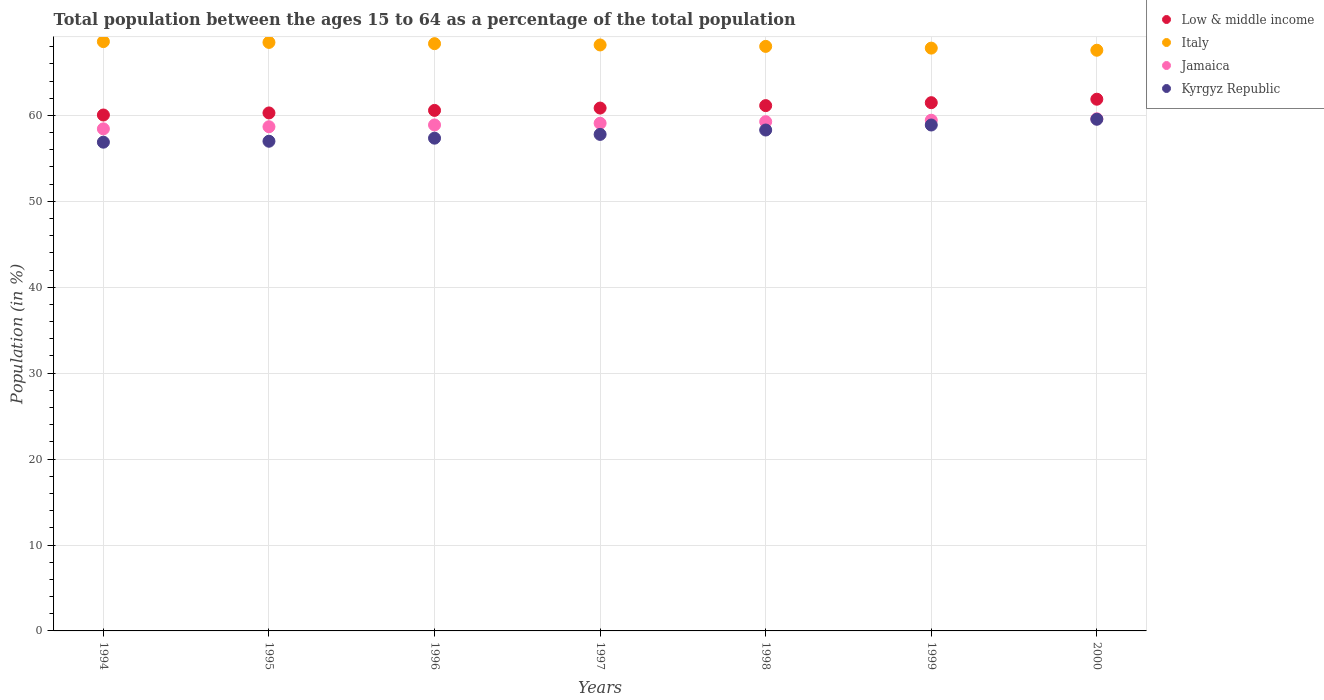How many different coloured dotlines are there?
Your answer should be very brief. 4. What is the percentage of the population ages 15 to 64 in Jamaica in 1996?
Offer a very short reply. 58.89. Across all years, what is the maximum percentage of the population ages 15 to 64 in Jamaica?
Your answer should be very brief. 59.61. Across all years, what is the minimum percentage of the population ages 15 to 64 in Jamaica?
Offer a very short reply. 58.43. In which year was the percentage of the population ages 15 to 64 in Low & middle income maximum?
Keep it short and to the point. 2000. In which year was the percentage of the population ages 15 to 64 in Jamaica minimum?
Make the answer very short. 1994. What is the total percentage of the population ages 15 to 64 in Low & middle income in the graph?
Provide a short and direct response. 426.27. What is the difference between the percentage of the population ages 15 to 64 in Low & middle income in 1996 and that in 1998?
Your answer should be compact. -0.56. What is the difference between the percentage of the population ages 15 to 64 in Low & middle income in 1998 and the percentage of the population ages 15 to 64 in Kyrgyz Republic in 1994?
Provide a succinct answer. 4.26. What is the average percentage of the population ages 15 to 64 in Kyrgyz Republic per year?
Provide a succinct answer. 57.96. In the year 1994, what is the difference between the percentage of the population ages 15 to 64 in Jamaica and percentage of the population ages 15 to 64 in Low & middle income?
Your answer should be very brief. -1.61. What is the ratio of the percentage of the population ages 15 to 64 in Kyrgyz Republic in 1994 to that in 1998?
Offer a terse response. 0.98. What is the difference between the highest and the second highest percentage of the population ages 15 to 64 in Jamaica?
Your answer should be very brief. 0.17. What is the difference between the highest and the lowest percentage of the population ages 15 to 64 in Italy?
Your answer should be very brief. 1.01. Is the sum of the percentage of the population ages 15 to 64 in Low & middle income in 1999 and 2000 greater than the maximum percentage of the population ages 15 to 64 in Kyrgyz Republic across all years?
Ensure brevity in your answer.  Yes. Is it the case that in every year, the sum of the percentage of the population ages 15 to 64 in Kyrgyz Republic and percentage of the population ages 15 to 64 in Jamaica  is greater than the sum of percentage of the population ages 15 to 64 in Low & middle income and percentage of the population ages 15 to 64 in Italy?
Provide a succinct answer. No. Does the percentage of the population ages 15 to 64 in Kyrgyz Republic monotonically increase over the years?
Offer a very short reply. Yes. How many years are there in the graph?
Ensure brevity in your answer.  7. What is the difference between two consecutive major ticks on the Y-axis?
Provide a succinct answer. 10. Are the values on the major ticks of Y-axis written in scientific E-notation?
Your answer should be very brief. No. What is the title of the graph?
Make the answer very short. Total population between the ages 15 to 64 as a percentage of the total population. What is the label or title of the X-axis?
Your answer should be very brief. Years. What is the label or title of the Y-axis?
Give a very brief answer. Population (in %). What is the Population (in %) in Low & middle income in 1994?
Provide a short and direct response. 60.05. What is the Population (in %) in Italy in 1994?
Provide a short and direct response. 68.59. What is the Population (in %) in Jamaica in 1994?
Ensure brevity in your answer.  58.43. What is the Population (in %) of Kyrgyz Republic in 1994?
Provide a short and direct response. 56.88. What is the Population (in %) in Low & middle income in 1995?
Make the answer very short. 60.29. What is the Population (in %) in Italy in 1995?
Your answer should be very brief. 68.5. What is the Population (in %) of Jamaica in 1995?
Offer a terse response. 58.68. What is the Population (in %) in Kyrgyz Republic in 1995?
Your answer should be compact. 56.99. What is the Population (in %) in Low & middle income in 1996?
Provide a succinct answer. 60.58. What is the Population (in %) in Italy in 1996?
Your response must be concise. 68.35. What is the Population (in %) in Jamaica in 1996?
Make the answer very short. 58.89. What is the Population (in %) in Kyrgyz Republic in 1996?
Your answer should be compact. 57.35. What is the Population (in %) of Low & middle income in 1997?
Your answer should be compact. 60.85. What is the Population (in %) in Italy in 1997?
Provide a succinct answer. 68.2. What is the Population (in %) in Jamaica in 1997?
Keep it short and to the point. 59.09. What is the Population (in %) in Kyrgyz Republic in 1997?
Provide a short and direct response. 57.79. What is the Population (in %) in Low & middle income in 1998?
Your response must be concise. 61.14. What is the Population (in %) of Italy in 1998?
Keep it short and to the point. 68.03. What is the Population (in %) of Jamaica in 1998?
Make the answer very short. 59.27. What is the Population (in %) of Kyrgyz Republic in 1998?
Make the answer very short. 58.3. What is the Population (in %) of Low & middle income in 1999?
Offer a terse response. 61.48. What is the Population (in %) of Italy in 1999?
Give a very brief answer. 67.83. What is the Population (in %) of Jamaica in 1999?
Provide a succinct answer. 59.44. What is the Population (in %) of Kyrgyz Republic in 1999?
Give a very brief answer. 58.88. What is the Population (in %) in Low & middle income in 2000?
Give a very brief answer. 61.88. What is the Population (in %) in Italy in 2000?
Your answer should be very brief. 67.58. What is the Population (in %) of Jamaica in 2000?
Ensure brevity in your answer.  59.61. What is the Population (in %) of Kyrgyz Republic in 2000?
Your answer should be very brief. 59.55. Across all years, what is the maximum Population (in %) of Low & middle income?
Ensure brevity in your answer.  61.88. Across all years, what is the maximum Population (in %) of Italy?
Keep it short and to the point. 68.59. Across all years, what is the maximum Population (in %) of Jamaica?
Your answer should be very brief. 59.61. Across all years, what is the maximum Population (in %) of Kyrgyz Republic?
Provide a succinct answer. 59.55. Across all years, what is the minimum Population (in %) in Low & middle income?
Keep it short and to the point. 60.05. Across all years, what is the minimum Population (in %) in Italy?
Offer a terse response. 67.58. Across all years, what is the minimum Population (in %) of Jamaica?
Make the answer very short. 58.43. Across all years, what is the minimum Population (in %) of Kyrgyz Republic?
Ensure brevity in your answer.  56.88. What is the total Population (in %) in Low & middle income in the graph?
Ensure brevity in your answer.  426.27. What is the total Population (in %) in Italy in the graph?
Provide a short and direct response. 477.08. What is the total Population (in %) of Jamaica in the graph?
Your answer should be very brief. 413.41. What is the total Population (in %) in Kyrgyz Republic in the graph?
Your answer should be compact. 405.75. What is the difference between the Population (in %) of Low & middle income in 1994 and that in 1995?
Offer a very short reply. -0.24. What is the difference between the Population (in %) of Italy in 1994 and that in 1995?
Provide a succinct answer. 0.09. What is the difference between the Population (in %) in Jamaica in 1994 and that in 1995?
Your answer should be compact. -0.25. What is the difference between the Population (in %) in Kyrgyz Republic in 1994 and that in 1995?
Keep it short and to the point. -0.11. What is the difference between the Population (in %) in Low & middle income in 1994 and that in 1996?
Your answer should be compact. -0.54. What is the difference between the Population (in %) in Italy in 1994 and that in 1996?
Provide a succinct answer. 0.24. What is the difference between the Population (in %) in Jamaica in 1994 and that in 1996?
Your answer should be very brief. -0.45. What is the difference between the Population (in %) of Kyrgyz Republic in 1994 and that in 1996?
Offer a very short reply. -0.47. What is the difference between the Population (in %) of Low & middle income in 1994 and that in 1997?
Provide a succinct answer. -0.81. What is the difference between the Population (in %) of Italy in 1994 and that in 1997?
Keep it short and to the point. 0.39. What is the difference between the Population (in %) in Jamaica in 1994 and that in 1997?
Provide a short and direct response. -0.65. What is the difference between the Population (in %) of Kyrgyz Republic in 1994 and that in 1997?
Provide a short and direct response. -0.91. What is the difference between the Population (in %) in Low & middle income in 1994 and that in 1998?
Your response must be concise. -1.09. What is the difference between the Population (in %) in Italy in 1994 and that in 1998?
Provide a succinct answer. 0.56. What is the difference between the Population (in %) in Jamaica in 1994 and that in 1998?
Provide a short and direct response. -0.84. What is the difference between the Population (in %) of Kyrgyz Republic in 1994 and that in 1998?
Your answer should be compact. -1.41. What is the difference between the Population (in %) of Low & middle income in 1994 and that in 1999?
Ensure brevity in your answer.  -1.43. What is the difference between the Population (in %) of Italy in 1994 and that in 1999?
Make the answer very short. 0.76. What is the difference between the Population (in %) of Jamaica in 1994 and that in 1999?
Your answer should be very brief. -1.01. What is the difference between the Population (in %) in Kyrgyz Republic in 1994 and that in 1999?
Your response must be concise. -2. What is the difference between the Population (in %) in Low & middle income in 1994 and that in 2000?
Offer a very short reply. -1.84. What is the difference between the Population (in %) of Italy in 1994 and that in 2000?
Offer a very short reply. 1. What is the difference between the Population (in %) of Jamaica in 1994 and that in 2000?
Provide a short and direct response. -1.17. What is the difference between the Population (in %) of Kyrgyz Republic in 1994 and that in 2000?
Keep it short and to the point. -2.67. What is the difference between the Population (in %) of Low & middle income in 1995 and that in 1996?
Keep it short and to the point. -0.3. What is the difference between the Population (in %) in Italy in 1995 and that in 1996?
Offer a very short reply. 0.14. What is the difference between the Population (in %) in Jamaica in 1995 and that in 1996?
Provide a succinct answer. -0.21. What is the difference between the Population (in %) in Kyrgyz Republic in 1995 and that in 1996?
Your response must be concise. -0.36. What is the difference between the Population (in %) in Low & middle income in 1995 and that in 1997?
Your answer should be compact. -0.57. What is the difference between the Population (in %) of Italy in 1995 and that in 1997?
Give a very brief answer. 0.3. What is the difference between the Population (in %) of Jamaica in 1995 and that in 1997?
Offer a terse response. -0.4. What is the difference between the Population (in %) in Kyrgyz Republic in 1995 and that in 1997?
Offer a terse response. -0.8. What is the difference between the Population (in %) in Low & middle income in 1995 and that in 1998?
Offer a very short reply. -0.85. What is the difference between the Population (in %) of Italy in 1995 and that in 1998?
Make the answer very short. 0.46. What is the difference between the Population (in %) of Jamaica in 1995 and that in 1998?
Provide a succinct answer. -0.59. What is the difference between the Population (in %) of Kyrgyz Republic in 1995 and that in 1998?
Provide a succinct answer. -1.31. What is the difference between the Population (in %) of Low & middle income in 1995 and that in 1999?
Make the answer very short. -1.19. What is the difference between the Population (in %) of Italy in 1995 and that in 1999?
Your answer should be compact. 0.66. What is the difference between the Population (in %) of Jamaica in 1995 and that in 1999?
Keep it short and to the point. -0.76. What is the difference between the Population (in %) of Kyrgyz Republic in 1995 and that in 1999?
Offer a terse response. -1.89. What is the difference between the Population (in %) in Low & middle income in 1995 and that in 2000?
Keep it short and to the point. -1.6. What is the difference between the Population (in %) of Italy in 1995 and that in 2000?
Provide a short and direct response. 0.91. What is the difference between the Population (in %) in Jamaica in 1995 and that in 2000?
Offer a very short reply. -0.93. What is the difference between the Population (in %) in Kyrgyz Republic in 1995 and that in 2000?
Your answer should be compact. -2.56. What is the difference between the Population (in %) of Low & middle income in 1996 and that in 1997?
Your response must be concise. -0.27. What is the difference between the Population (in %) in Italy in 1996 and that in 1997?
Make the answer very short. 0.15. What is the difference between the Population (in %) of Jamaica in 1996 and that in 1997?
Provide a succinct answer. -0.2. What is the difference between the Population (in %) in Kyrgyz Republic in 1996 and that in 1997?
Ensure brevity in your answer.  -0.44. What is the difference between the Population (in %) of Low & middle income in 1996 and that in 1998?
Give a very brief answer. -0.56. What is the difference between the Population (in %) in Italy in 1996 and that in 1998?
Offer a very short reply. 0.32. What is the difference between the Population (in %) of Jamaica in 1996 and that in 1998?
Provide a succinct answer. -0.38. What is the difference between the Population (in %) of Kyrgyz Republic in 1996 and that in 1998?
Your answer should be compact. -0.95. What is the difference between the Population (in %) in Low & middle income in 1996 and that in 1999?
Your answer should be very brief. -0.9. What is the difference between the Population (in %) of Italy in 1996 and that in 1999?
Make the answer very short. 0.52. What is the difference between the Population (in %) of Jamaica in 1996 and that in 1999?
Your answer should be very brief. -0.55. What is the difference between the Population (in %) of Kyrgyz Republic in 1996 and that in 1999?
Provide a succinct answer. -1.53. What is the difference between the Population (in %) of Low & middle income in 1996 and that in 2000?
Make the answer very short. -1.3. What is the difference between the Population (in %) of Italy in 1996 and that in 2000?
Your response must be concise. 0.77. What is the difference between the Population (in %) in Jamaica in 1996 and that in 2000?
Your response must be concise. -0.72. What is the difference between the Population (in %) in Kyrgyz Republic in 1996 and that in 2000?
Your answer should be compact. -2.2. What is the difference between the Population (in %) of Low & middle income in 1997 and that in 1998?
Provide a short and direct response. -0.28. What is the difference between the Population (in %) of Italy in 1997 and that in 1998?
Your answer should be compact. 0.17. What is the difference between the Population (in %) in Jamaica in 1997 and that in 1998?
Ensure brevity in your answer.  -0.19. What is the difference between the Population (in %) in Kyrgyz Republic in 1997 and that in 1998?
Keep it short and to the point. -0.51. What is the difference between the Population (in %) in Low & middle income in 1997 and that in 1999?
Ensure brevity in your answer.  -0.63. What is the difference between the Population (in %) in Italy in 1997 and that in 1999?
Ensure brevity in your answer.  0.37. What is the difference between the Population (in %) of Jamaica in 1997 and that in 1999?
Your answer should be compact. -0.35. What is the difference between the Population (in %) in Kyrgyz Republic in 1997 and that in 1999?
Your response must be concise. -1.09. What is the difference between the Population (in %) in Low & middle income in 1997 and that in 2000?
Your answer should be compact. -1.03. What is the difference between the Population (in %) in Italy in 1997 and that in 2000?
Your answer should be very brief. 0.62. What is the difference between the Population (in %) in Jamaica in 1997 and that in 2000?
Make the answer very short. -0.52. What is the difference between the Population (in %) of Kyrgyz Republic in 1997 and that in 2000?
Offer a terse response. -1.76. What is the difference between the Population (in %) in Low & middle income in 1998 and that in 1999?
Provide a succinct answer. -0.34. What is the difference between the Population (in %) of Italy in 1998 and that in 1999?
Ensure brevity in your answer.  0.2. What is the difference between the Population (in %) in Jamaica in 1998 and that in 1999?
Your answer should be very brief. -0.17. What is the difference between the Population (in %) in Kyrgyz Republic in 1998 and that in 1999?
Give a very brief answer. -0.58. What is the difference between the Population (in %) of Low & middle income in 1998 and that in 2000?
Your answer should be compact. -0.75. What is the difference between the Population (in %) of Italy in 1998 and that in 2000?
Provide a short and direct response. 0.45. What is the difference between the Population (in %) of Jamaica in 1998 and that in 2000?
Offer a very short reply. -0.34. What is the difference between the Population (in %) of Kyrgyz Republic in 1998 and that in 2000?
Give a very brief answer. -1.25. What is the difference between the Population (in %) in Low & middle income in 1999 and that in 2000?
Give a very brief answer. -0.4. What is the difference between the Population (in %) in Italy in 1999 and that in 2000?
Your answer should be compact. 0.25. What is the difference between the Population (in %) of Jamaica in 1999 and that in 2000?
Make the answer very short. -0.17. What is the difference between the Population (in %) of Kyrgyz Republic in 1999 and that in 2000?
Provide a succinct answer. -0.67. What is the difference between the Population (in %) in Low & middle income in 1994 and the Population (in %) in Italy in 1995?
Keep it short and to the point. -8.45. What is the difference between the Population (in %) of Low & middle income in 1994 and the Population (in %) of Jamaica in 1995?
Offer a very short reply. 1.37. What is the difference between the Population (in %) of Low & middle income in 1994 and the Population (in %) of Kyrgyz Republic in 1995?
Your answer should be very brief. 3.05. What is the difference between the Population (in %) in Italy in 1994 and the Population (in %) in Jamaica in 1995?
Offer a terse response. 9.91. What is the difference between the Population (in %) in Italy in 1994 and the Population (in %) in Kyrgyz Republic in 1995?
Keep it short and to the point. 11.6. What is the difference between the Population (in %) of Jamaica in 1994 and the Population (in %) of Kyrgyz Republic in 1995?
Make the answer very short. 1.44. What is the difference between the Population (in %) of Low & middle income in 1994 and the Population (in %) of Italy in 1996?
Provide a succinct answer. -8.3. What is the difference between the Population (in %) of Low & middle income in 1994 and the Population (in %) of Jamaica in 1996?
Provide a short and direct response. 1.16. What is the difference between the Population (in %) of Low & middle income in 1994 and the Population (in %) of Kyrgyz Republic in 1996?
Your response must be concise. 2.7. What is the difference between the Population (in %) of Italy in 1994 and the Population (in %) of Jamaica in 1996?
Your answer should be compact. 9.7. What is the difference between the Population (in %) in Italy in 1994 and the Population (in %) in Kyrgyz Republic in 1996?
Your response must be concise. 11.24. What is the difference between the Population (in %) in Jamaica in 1994 and the Population (in %) in Kyrgyz Republic in 1996?
Keep it short and to the point. 1.08. What is the difference between the Population (in %) of Low & middle income in 1994 and the Population (in %) of Italy in 1997?
Your response must be concise. -8.15. What is the difference between the Population (in %) in Low & middle income in 1994 and the Population (in %) in Jamaica in 1997?
Make the answer very short. 0.96. What is the difference between the Population (in %) in Low & middle income in 1994 and the Population (in %) in Kyrgyz Republic in 1997?
Provide a succinct answer. 2.26. What is the difference between the Population (in %) in Italy in 1994 and the Population (in %) in Jamaica in 1997?
Provide a short and direct response. 9.5. What is the difference between the Population (in %) in Italy in 1994 and the Population (in %) in Kyrgyz Republic in 1997?
Offer a very short reply. 10.8. What is the difference between the Population (in %) in Jamaica in 1994 and the Population (in %) in Kyrgyz Republic in 1997?
Offer a very short reply. 0.64. What is the difference between the Population (in %) in Low & middle income in 1994 and the Population (in %) in Italy in 1998?
Make the answer very short. -7.99. What is the difference between the Population (in %) of Low & middle income in 1994 and the Population (in %) of Jamaica in 1998?
Your answer should be very brief. 0.78. What is the difference between the Population (in %) of Low & middle income in 1994 and the Population (in %) of Kyrgyz Republic in 1998?
Keep it short and to the point. 1.75. What is the difference between the Population (in %) in Italy in 1994 and the Population (in %) in Jamaica in 1998?
Give a very brief answer. 9.32. What is the difference between the Population (in %) in Italy in 1994 and the Population (in %) in Kyrgyz Republic in 1998?
Offer a terse response. 10.29. What is the difference between the Population (in %) in Jamaica in 1994 and the Population (in %) in Kyrgyz Republic in 1998?
Provide a succinct answer. 0.13. What is the difference between the Population (in %) of Low & middle income in 1994 and the Population (in %) of Italy in 1999?
Provide a succinct answer. -7.78. What is the difference between the Population (in %) in Low & middle income in 1994 and the Population (in %) in Jamaica in 1999?
Provide a short and direct response. 0.61. What is the difference between the Population (in %) of Low & middle income in 1994 and the Population (in %) of Kyrgyz Republic in 1999?
Provide a short and direct response. 1.16. What is the difference between the Population (in %) of Italy in 1994 and the Population (in %) of Jamaica in 1999?
Give a very brief answer. 9.15. What is the difference between the Population (in %) in Italy in 1994 and the Population (in %) in Kyrgyz Republic in 1999?
Make the answer very short. 9.71. What is the difference between the Population (in %) of Jamaica in 1994 and the Population (in %) of Kyrgyz Republic in 1999?
Give a very brief answer. -0.45. What is the difference between the Population (in %) in Low & middle income in 1994 and the Population (in %) in Italy in 2000?
Offer a very short reply. -7.54. What is the difference between the Population (in %) of Low & middle income in 1994 and the Population (in %) of Jamaica in 2000?
Ensure brevity in your answer.  0.44. What is the difference between the Population (in %) of Low & middle income in 1994 and the Population (in %) of Kyrgyz Republic in 2000?
Your answer should be compact. 0.5. What is the difference between the Population (in %) in Italy in 1994 and the Population (in %) in Jamaica in 2000?
Offer a very short reply. 8.98. What is the difference between the Population (in %) in Italy in 1994 and the Population (in %) in Kyrgyz Republic in 2000?
Your response must be concise. 9.04. What is the difference between the Population (in %) of Jamaica in 1994 and the Population (in %) of Kyrgyz Republic in 2000?
Provide a succinct answer. -1.12. What is the difference between the Population (in %) in Low & middle income in 1995 and the Population (in %) in Italy in 1996?
Provide a short and direct response. -8.06. What is the difference between the Population (in %) in Low & middle income in 1995 and the Population (in %) in Jamaica in 1996?
Your response must be concise. 1.4. What is the difference between the Population (in %) in Low & middle income in 1995 and the Population (in %) in Kyrgyz Republic in 1996?
Keep it short and to the point. 2.94. What is the difference between the Population (in %) of Italy in 1995 and the Population (in %) of Jamaica in 1996?
Give a very brief answer. 9.61. What is the difference between the Population (in %) of Italy in 1995 and the Population (in %) of Kyrgyz Republic in 1996?
Ensure brevity in your answer.  11.14. What is the difference between the Population (in %) in Jamaica in 1995 and the Population (in %) in Kyrgyz Republic in 1996?
Ensure brevity in your answer.  1.33. What is the difference between the Population (in %) of Low & middle income in 1995 and the Population (in %) of Italy in 1997?
Ensure brevity in your answer.  -7.91. What is the difference between the Population (in %) of Low & middle income in 1995 and the Population (in %) of Jamaica in 1997?
Your answer should be compact. 1.2. What is the difference between the Population (in %) in Low & middle income in 1995 and the Population (in %) in Kyrgyz Republic in 1997?
Provide a succinct answer. 2.5. What is the difference between the Population (in %) in Italy in 1995 and the Population (in %) in Jamaica in 1997?
Offer a very short reply. 9.41. What is the difference between the Population (in %) of Italy in 1995 and the Population (in %) of Kyrgyz Republic in 1997?
Keep it short and to the point. 10.71. What is the difference between the Population (in %) in Jamaica in 1995 and the Population (in %) in Kyrgyz Republic in 1997?
Offer a very short reply. 0.89. What is the difference between the Population (in %) of Low & middle income in 1995 and the Population (in %) of Italy in 1998?
Offer a very short reply. -7.75. What is the difference between the Population (in %) of Low & middle income in 1995 and the Population (in %) of Jamaica in 1998?
Your response must be concise. 1.02. What is the difference between the Population (in %) of Low & middle income in 1995 and the Population (in %) of Kyrgyz Republic in 1998?
Your answer should be very brief. 1.99. What is the difference between the Population (in %) in Italy in 1995 and the Population (in %) in Jamaica in 1998?
Provide a short and direct response. 9.22. What is the difference between the Population (in %) in Italy in 1995 and the Population (in %) in Kyrgyz Republic in 1998?
Keep it short and to the point. 10.2. What is the difference between the Population (in %) in Jamaica in 1995 and the Population (in %) in Kyrgyz Republic in 1998?
Ensure brevity in your answer.  0.38. What is the difference between the Population (in %) of Low & middle income in 1995 and the Population (in %) of Italy in 1999?
Keep it short and to the point. -7.54. What is the difference between the Population (in %) in Low & middle income in 1995 and the Population (in %) in Jamaica in 1999?
Offer a very short reply. 0.85. What is the difference between the Population (in %) of Low & middle income in 1995 and the Population (in %) of Kyrgyz Republic in 1999?
Offer a very short reply. 1.4. What is the difference between the Population (in %) of Italy in 1995 and the Population (in %) of Jamaica in 1999?
Offer a very short reply. 9.06. What is the difference between the Population (in %) of Italy in 1995 and the Population (in %) of Kyrgyz Republic in 1999?
Keep it short and to the point. 9.61. What is the difference between the Population (in %) of Jamaica in 1995 and the Population (in %) of Kyrgyz Republic in 1999?
Your response must be concise. -0.2. What is the difference between the Population (in %) in Low & middle income in 1995 and the Population (in %) in Italy in 2000?
Offer a terse response. -7.3. What is the difference between the Population (in %) in Low & middle income in 1995 and the Population (in %) in Jamaica in 2000?
Offer a very short reply. 0.68. What is the difference between the Population (in %) of Low & middle income in 1995 and the Population (in %) of Kyrgyz Republic in 2000?
Offer a terse response. 0.74. What is the difference between the Population (in %) in Italy in 1995 and the Population (in %) in Jamaica in 2000?
Your answer should be compact. 8.89. What is the difference between the Population (in %) of Italy in 1995 and the Population (in %) of Kyrgyz Republic in 2000?
Your response must be concise. 8.94. What is the difference between the Population (in %) in Jamaica in 1995 and the Population (in %) in Kyrgyz Republic in 2000?
Your response must be concise. -0.87. What is the difference between the Population (in %) in Low & middle income in 1996 and the Population (in %) in Italy in 1997?
Offer a terse response. -7.62. What is the difference between the Population (in %) in Low & middle income in 1996 and the Population (in %) in Jamaica in 1997?
Offer a very short reply. 1.5. What is the difference between the Population (in %) in Low & middle income in 1996 and the Population (in %) in Kyrgyz Republic in 1997?
Offer a very short reply. 2.79. What is the difference between the Population (in %) in Italy in 1996 and the Population (in %) in Jamaica in 1997?
Keep it short and to the point. 9.27. What is the difference between the Population (in %) in Italy in 1996 and the Population (in %) in Kyrgyz Republic in 1997?
Give a very brief answer. 10.56. What is the difference between the Population (in %) of Jamaica in 1996 and the Population (in %) of Kyrgyz Republic in 1997?
Your answer should be compact. 1.1. What is the difference between the Population (in %) of Low & middle income in 1996 and the Population (in %) of Italy in 1998?
Your answer should be very brief. -7.45. What is the difference between the Population (in %) in Low & middle income in 1996 and the Population (in %) in Jamaica in 1998?
Offer a very short reply. 1.31. What is the difference between the Population (in %) of Low & middle income in 1996 and the Population (in %) of Kyrgyz Republic in 1998?
Your answer should be very brief. 2.28. What is the difference between the Population (in %) of Italy in 1996 and the Population (in %) of Jamaica in 1998?
Your answer should be compact. 9.08. What is the difference between the Population (in %) in Italy in 1996 and the Population (in %) in Kyrgyz Republic in 1998?
Your answer should be very brief. 10.05. What is the difference between the Population (in %) of Jamaica in 1996 and the Population (in %) of Kyrgyz Republic in 1998?
Give a very brief answer. 0.59. What is the difference between the Population (in %) of Low & middle income in 1996 and the Population (in %) of Italy in 1999?
Provide a succinct answer. -7.25. What is the difference between the Population (in %) of Low & middle income in 1996 and the Population (in %) of Jamaica in 1999?
Offer a terse response. 1.14. What is the difference between the Population (in %) of Low & middle income in 1996 and the Population (in %) of Kyrgyz Republic in 1999?
Your response must be concise. 1.7. What is the difference between the Population (in %) in Italy in 1996 and the Population (in %) in Jamaica in 1999?
Ensure brevity in your answer.  8.91. What is the difference between the Population (in %) in Italy in 1996 and the Population (in %) in Kyrgyz Republic in 1999?
Give a very brief answer. 9.47. What is the difference between the Population (in %) of Jamaica in 1996 and the Population (in %) of Kyrgyz Republic in 1999?
Your answer should be compact. 0.01. What is the difference between the Population (in %) in Low & middle income in 1996 and the Population (in %) in Italy in 2000?
Provide a succinct answer. -7. What is the difference between the Population (in %) of Low & middle income in 1996 and the Population (in %) of Jamaica in 2000?
Provide a short and direct response. 0.97. What is the difference between the Population (in %) of Low & middle income in 1996 and the Population (in %) of Kyrgyz Republic in 2000?
Your answer should be very brief. 1.03. What is the difference between the Population (in %) of Italy in 1996 and the Population (in %) of Jamaica in 2000?
Give a very brief answer. 8.74. What is the difference between the Population (in %) of Italy in 1996 and the Population (in %) of Kyrgyz Republic in 2000?
Keep it short and to the point. 8.8. What is the difference between the Population (in %) of Jamaica in 1996 and the Population (in %) of Kyrgyz Republic in 2000?
Your response must be concise. -0.66. What is the difference between the Population (in %) in Low & middle income in 1997 and the Population (in %) in Italy in 1998?
Ensure brevity in your answer.  -7.18. What is the difference between the Population (in %) of Low & middle income in 1997 and the Population (in %) of Jamaica in 1998?
Your answer should be very brief. 1.58. What is the difference between the Population (in %) in Low & middle income in 1997 and the Population (in %) in Kyrgyz Republic in 1998?
Give a very brief answer. 2.56. What is the difference between the Population (in %) of Italy in 1997 and the Population (in %) of Jamaica in 1998?
Ensure brevity in your answer.  8.93. What is the difference between the Population (in %) in Italy in 1997 and the Population (in %) in Kyrgyz Republic in 1998?
Offer a very short reply. 9.9. What is the difference between the Population (in %) in Jamaica in 1997 and the Population (in %) in Kyrgyz Republic in 1998?
Provide a succinct answer. 0.79. What is the difference between the Population (in %) of Low & middle income in 1997 and the Population (in %) of Italy in 1999?
Make the answer very short. -6.98. What is the difference between the Population (in %) in Low & middle income in 1997 and the Population (in %) in Jamaica in 1999?
Your answer should be compact. 1.41. What is the difference between the Population (in %) of Low & middle income in 1997 and the Population (in %) of Kyrgyz Republic in 1999?
Keep it short and to the point. 1.97. What is the difference between the Population (in %) in Italy in 1997 and the Population (in %) in Jamaica in 1999?
Ensure brevity in your answer.  8.76. What is the difference between the Population (in %) in Italy in 1997 and the Population (in %) in Kyrgyz Republic in 1999?
Provide a succinct answer. 9.32. What is the difference between the Population (in %) of Jamaica in 1997 and the Population (in %) of Kyrgyz Republic in 1999?
Provide a succinct answer. 0.2. What is the difference between the Population (in %) of Low & middle income in 1997 and the Population (in %) of Italy in 2000?
Offer a terse response. -6.73. What is the difference between the Population (in %) in Low & middle income in 1997 and the Population (in %) in Jamaica in 2000?
Offer a terse response. 1.25. What is the difference between the Population (in %) in Low & middle income in 1997 and the Population (in %) in Kyrgyz Republic in 2000?
Your response must be concise. 1.3. What is the difference between the Population (in %) of Italy in 1997 and the Population (in %) of Jamaica in 2000?
Offer a terse response. 8.59. What is the difference between the Population (in %) of Italy in 1997 and the Population (in %) of Kyrgyz Republic in 2000?
Offer a terse response. 8.65. What is the difference between the Population (in %) of Jamaica in 1997 and the Population (in %) of Kyrgyz Republic in 2000?
Offer a very short reply. -0.47. What is the difference between the Population (in %) of Low & middle income in 1998 and the Population (in %) of Italy in 1999?
Ensure brevity in your answer.  -6.69. What is the difference between the Population (in %) in Low & middle income in 1998 and the Population (in %) in Jamaica in 1999?
Give a very brief answer. 1.7. What is the difference between the Population (in %) of Low & middle income in 1998 and the Population (in %) of Kyrgyz Republic in 1999?
Provide a succinct answer. 2.26. What is the difference between the Population (in %) in Italy in 1998 and the Population (in %) in Jamaica in 1999?
Give a very brief answer. 8.59. What is the difference between the Population (in %) of Italy in 1998 and the Population (in %) of Kyrgyz Republic in 1999?
Make the answer very short. 9.15. What is the difference between the Population (in %) in Jamaica in 1998 and the Population (in %) in Kyrgyz Republic in 1999?
Keep it short and to the point. 0.39. What is the difference between the Population (in %) in Low & middle income in 1998 and the Population (in %) in Italy in 2000?
Your answer should be very brief. -6.45. What is the difference between the Population (in %) of Low & middle income in 1998 and the Population (in %) of Jamaica in 2000?
Your response must be concise. 1.53. What is the difference between the Population (in %) of Low & middle income in 1998 and the Population (in %) of Kyrgyz Republic in 2000?
Provide a succinct answer. 1.59. What is the difference between the Population (in %) in Italy in 1998 and the Population (in %) in Jamaica in 2000?
Provide a succinct answer. 8.42. What is the difference between the Population (in %) of Italy in 1998 and the Population (in %) of Kyrgyz Republic in 2000?
Provide a short and direct response. 8.48. What is the difference between the Population (in %) of Jamaica in 1998 and the Population (in %) of Kyrgyz Republic in 2000?
Ensure brevity in your answer.  -0.28. What is the difference between the Population (in %) of Low & middle income in 1999 and the Population (in %) of Italy in 2000?
Make the answer very short. -6.1. What is the difference between the Population (in %) of Low & middle income in 1999 and the Population (in %) of Jamaica in 2000?
Provide a succinct answer. 1.87. What is the difference between the Population (in %) in Low & middle income in 1999 and the Population (in %) in Kyrgyz Republic in 2000?
Offer a terse response. 1.93. What is the difference between the Population (in %) of Italy in 1999 and the Population (in %) of Jamaica in 2000?
Your answer should be compact. 8.22. What is the difference between the Population (in %) of Italy in 1999 and the Population (in %) of Kyrgyz Republic in 2000?
Ensure brevity in your answer.  8.28. What is the difference between the Population (in %) in Jamaica in 1999 and the Population (in %) in Kyrgyz Republic in 2000?
Your answer should be very brief. -0.11. What is the average Population (in %) of Low & middle income per year?
Your answer should be compact. 60.9. What is the average Population (in %) of Italy per year?
Give a very brief answer. 68.15. What is the average Population (in %) in Jamaica per year?
Your answer should be very brief. 59.06. What is the average Population (in %) in Kyrgyz Republic per year?
Your answer should be compact. 57.96. In the year 1994, what is the difference between the Population (in %) in Low & middle income and Population (in %) in Italy?
Offer a terse response. -8.54. In the year 1994, what is the difference between the Population (in %) of Low & middle income and Population (in %) of Jamaica?
Give a very brief answer. 1.61. In the year 1994, what is the difference between the Population (in %) of Low & middle income and Population (in %) of Kyrgyz Republic?
Your answer should be very brief. 3.16. In the year 1994, what is the difference between the Population (in %) in Italy and Population (in %) in Jamaica?
Your answer should be compact. 10.16. In the year 1994, what is the difference between the Population (in %) in Italy and Population (in %) in Kyrgyz Republic?
Ensure brevity in your answer.  11.71. In the year 1994, what is the difference between the Population (in %) of Jamaica and Population (in %) of Kyrgyz Republic?
Your answer should be compact. 1.55. In the year 1995, what is the difference between the Population (in %) in Low & middle income and Population (in %) in Italy?
Provide a short and direct response. -8.21. In the year 1995, what is the difference between the Population (in %) in Low & middle income and Population (in %) in Jamaica?
Provide a short and direct response. 1.61. In the year 1995, what is the difference between the Population (in %) in Low & middle income and Population (in %) in Kyrgyz Republic?
Provide a short and direct response. 3.29. In the year 1995, what is the difference between the Population (in %) of Italy and Population (in %) of Jamaica?
Make the answer very short. 9.81. In the year 1995, what is the difference between the Population (in %) of Italy and Population (in %) of Kyrgyz Republic?
Your answer should be compact. 11.5. In the year 1995, what is the difference between the Population (in %) in Jamaica and Population (in %) in Kyrgyz Republic?
Your response must be concise. 1.69. In the year 1996, what is the difference between the Population (in %) in Low & middle income and Population (in %) in Italy?
Provide a succinct answer. -7.77. In the year 1996, what is the difference between the Population (in %) in Low & middle income and Population (in %) in Jamaica?
Make the answer very short. 1.69. In the year 1996, what is the difference between the Population (in %) in Low & middle income and Population (in %) in Kyrgyz Republic?
Your answer should be very brief. 3.23. In the year 1996, what is the difference between the Population (in %) in Italy and Population (in %) in Jamaica?
Provide a succinct answer. 9.46. In the year 1996, what is the difference between the Population (in %) of Italy and Population (in %) of Kyrgyz Republic?
Your answer should be very brief. 11. In the year 1996, what is the difference between the Population (in %) of Jamaica and Population (in %) of Kyrgyz Republic?
Your response must be concise. 1.54. In the year 1997, what is the difference between the Population (in %) of Low & middle income and Population (in %) of Italy?
Give a very brief answer. -7.35. In the year 1997, what is the difference between the Population (in %) in Low & middle income and Population (in %) in Jamaica?
Offer a terse response. 1.77. In the year 1997, what is the difference between the Population (in %) of Low & middle income and Population (in %) of Kyrgyz Republic?
Keep it short and to the point. 3.06. In the year 1997, what is the difference between the Population (in %) in Italy and Population (in %) in Jamaica?
Offer a very short reply. 9.11. In the year 1997, what is the difference between the Population (in %) of Italy and Population (in %) of Kyrgyz Republic?
Keep it short and to the point. 10.41. In the year 1997, what is the difference between the Population (in %) in Jamaica and Population (in %) in Kyrgyz Republic?
Your answer should be very brief. 1.3. In the year 1998, what is the difference between the Population (in %) in Low & middle income and Population (in %) in Italy?
Ensure brevity in your answer.  -6.89. In the year 1998, what is the difference between the Population (in %) in Low & middle income and Population (in %) in Jamaica?
Keep it short and to the point. 1.87. In the year 1998, what is the difference between the Population (in %) in Low & middle income and Population (in %) in Kyrgyz Republic?
Give a very brief answer. 2.84. In the year 1998, what is the difference between the Population (in %) of Italy and Population (in %) of Jamaica?
Ensure brevity in your answer.  8.76. In the year 1998, what is the difference between the Population (in %) of Italy and Population (in %) of Kyrgyz Republic?
Offer a terse response. 9.73. In the year 1998, what is the difference between the Population (in %) of Jamaica and Population (in %) of Kyrgyz Republic?
Give a very brief answer. 0.97. In the year 1999, what is the difference between the Population (in %) of Low & middle income and Population (in %) of Italy?
Provide a succinct answer. -6.35. In the year 1999, what is the difference between the Population (in %) in Low & middle income and Population (in %) in Jamaica?
Provide a short and direct response. 2.04. In the year 1999, what is the difference between the Population (in %) of Low & middle income and Population (in %) of Kyrgyz Republic?
Offer a very short reply. 2.6. In the year 1999, what is the difference between the Population (in %) in Italy and Population (in %) in Jamaica?
Provide a succinct answer. 8.39. In the year 1999, what is the difference between the Population (in %) in Italy and Population (in %) in Kyrgyz Republic?
Keep it short and to the point. 8.95. In the year 1999, what is the difference between the Population (in %) of Jamaica and Population (in %) of Kyrgyz Republic?
Offer a very short reply. 0.56. In the year 2000, what is the difference between the Population (in %) of Low & middle income and Population (in %) of Italy?
Make the answer very short. -5.7. In the year 2000, what is the difference between the Population (in %) in Low & middle income and Population (in %) in Jamaica?
Offer a very short reply. 2.28. In the year 2000, what is the difference between the Population (in %) in Low & middle income and Population (in %) in Kyrgyz Republic?
Provide a short and direct response. 2.33. In the year 2000, what is the difference between the Population (in %) in Italy and Population (in %) in Jamaica?
Provide a succinct answer. 7.98. In the year 2000, what is the difference between the Population (in %) of Italy and Population (in %) of Kyrgyz Republic?
Offer a terse response. 8.03. In the year 2000, what is the difference between the Population (in %) in Jamaica and Population (in %) in Kyrgyz Republic?
Make the answer very short. 0.06. What is the ratio of the Population (in %) of Italy in 1994 to that in 1995?
Keep it short and to the point. 1. What is the ratio of the Population (in %) in Kyrgyz Republic in 1994 to that in 1995?
Keep it short and to the point. 1. What is the ratio of the Population (in %) of Jamaica in 1994 to that in 1996?
Your answer should be very brief. 0.99. What is the ratio of the Population (in %) in Kyrgyz Republic in 1994 to that in 1996?
Ensure brevity in your answer.  0.99. What is the ratio of the Population (in %) of Low & middle income in 1994 to that in 1997?
Ensure brevity in your answer.  0.99. What is the ratio of the Population (in %) of Jamaica in 1994 to that in 1997?
Ensure brevity in your answer.  0.99. What is the ratio of the Population (in %) in Kyrgyz Republic in 1994 to that in 1997?
Offer a very short reply. 0.98. What is the ratio of the Population (in %) of Low & middle income in 1994 to that in 1998?
Keep it short and to the point. 0.98. What is the ratio of the Population (in %) of Italy in 1994 to that in 1998?
Keep it short and to the point. 1.01. What is the ratio of the Population (in %) in Jamaica in 1994 to that in 1998?
Provide a succinct answer. 0.99. What is the ratio of the Population (in %) of Kyrgyz Republic in 1994 to that in 1998?
Your response must be concise. 0.98. What is the ratio of the Population (in %) in Low & middle income in 1994 to that in 1999?
Your answer should be compact. 0.98. What is the ratio of the Population (in %) of Italy in 1994 to that in 1999?
Keep it short and to the point. 1.01. What is the ratio of the Population (in %) of Jamaica in 1994 to that in 1999?
Ensure brevity in your answer.  0.98. What is the ratio of the Population (in %) in Kyrgyz Republic in 1994 to that in 1999?
Provide a succinct answer. 0.97. What is the ratio of the Population (in %) in Low & middle income in 1994 to that in 2000?
Keep it short and to the point. 0.97. What is the ratio of the Population (in %) in Italy in 1994 to that in 2000?
Your answer should be compact. 1.01. What is the ratio of the Population (in %) of Jamaica in 1994 to that in 2000?
Your answer should be compact. 0.98. What is the ratio of the Population (in %) of Kyrgyz Republic in 1994 to that in 2000?
Give a very brief answer. 0.96. What is the ratio of the Population (in %) of Low & middle income in 1995 to that in 1996?
Make the answer very short. 1. What is the ratio of the Population (in %) in Italy in 1995 to that in 1996?
Offer a very short reply. 1. What is the ratio of the Population (in %) in Jamaica in 1995 to that in 1996?
Your answer should be compact. 1. What is the ratio of the Population (in %) in Kyrgyz Republic in 1995 to that in 1996?
Your answer should be very brief. 0.99. What is the ratio of the Population (in %) in Kyrgyz Republic in 1995 to that in 1997?
Provide a short and direct response. 0.99. What is the ratio of the Population (in %) of Low & middle income in 1995 to that in 1998?
Give a very brief answer. 0.99. What is the ratio of the Population (in %) of Italy in 1995 to that in 1998?
Offer a very short reply. 1.01. What is the ratio of the Population (in %) in Jamaica in 1995 to that in 1998?
Ensure brevity in your answer.  0.99. What is the ratio of the Population (in %) in Kyrgyz Republic in 1995 to that in 1998?
Provide a short and direct response. 0.98. What is the ratio of the Population (in %) in Low & middle income in 1995 to that in 1999?
Keep it short and to the point. 0.98. What is the ratio of the Population (in %) in Italy in 1995 to that in 1999?
Ensure brevity in your answer.  1.01. What is the ratio of the Population (in %) in Jamaica in 1995 to that in 1999?
Give a very brief answer. 0.99. What is the ratio of the Population (in %) of Kyrgyz Republic in 1995 to that in 1999?
Make the answer very short. 0.97. What is the ratio of the Population (in %) in Low & middle income in 1995 to that in 2000?
Your answer should be compact. 0.97. What is the ratio of the Population (in %) of Italy in 1995 to that in 2000?
Keep it short and to the point. 1.01. What is the ratio of the Population (in %) of Jamaica in 1995 to that in 2000?
Your response must be concise. 0.98. What is the ratio of the Population (in %) in Kyrgyz Republic in 1995 to that in 2000?
Offer a terse response. 0.96. What is the ratio of the Population (in %) of Jamaica in 1996 to that in 1997?
Provide a succinct answer. 1. What is the ratio of the Population (in %) in Kyrgyz Republic in 1996 to that in 1997?
Your answer should be compact. 0.99. What is the ratio of the Population (in %) in Low & middle income in 1996 to that in 1998?
Your answer should be very brief. 0.99. What is the ratio of the Population (in %) in Kyrgyz Republic in 1996 to that in 1998?
Provide a succinct answer. 0.98. What is the ratio of the Population (in %) of Low & middle income in 1996 to that in 1999?
Your response must be concise. 0.99. What is the ratio of the Population (in %) in Italy in 1996 to that in 1999?
Keep it short and to the point. 1.01. What is the ratio of the Population (in %) of Jamaica in 1996 to that in 1999?
Ensure brevity in your answer.  0.99. What is the ratio of the Population (in %) of Low & middle income in 1996 to that in 2000?
Offer a very short reply. 0.98. What is the ratio of the Population (in %) of Italy in 1996 to that in 2000?
Ensure brevity in your answer.  1.01. What is the ratio of the Population (in %) in Jamaica in 1996 to that in 2000?
Offer a terse response. 0.99. What is the ratio of the Population (in %) of Kyrgyz Republic in 1996 to that in 2000?
Offer a terse response. 0.96. What is the ratio of the Population (in %) in Kyrgyz Republic in 1997 to that in 1998?
Make the answer very short. 0.99. What is the ratio of the Population (in %) in Low & middle income in 1997 to that in 1999?
Offer a very short reply. 0.99. What is the ratio of the Population (in %) in Italy in 1997 to that in 1999?
Make the answer very short. 1.01. What is the ratio of the Population (in %) of Kyrgyz Republic in 1997 to that in 1999?
Ensure brevity in your answer.  0.98. What is the ratio of the Population (in %) of Low & middle income in 1997 to that in 2000?
Make the answer very short. 0.98. What is the ratio of the Population (in %) of Italy in 1997 to that in 2000?
Ensure brevity in your answer.  1.01. What is the ratio of the Population (in %) in Jamaica in 1997 to that in 2000?
Your answer should be very brief. 0.99. What is the ratio of the Population (in %) of Kyrgyz Republic in 1997 to that in 2000?
Give a very brief answer. 0.97. What is the ratio of the Population (in %) of Low & middle income in 1998 to that in 1999?
Offer a very short reply. 0.99. What is the ratio of the Population (in %) of Italy in 1998 to that in 1999?
Give a very brief answer. 1. What is the ratio of the Population (in %) in Jamaica in 1998 to that in 1999?
Keep it short and to the point. 1. What is the ratio of the Population (in %) of Kyrgyz Republic in 1998 to that in 1999?
Offer a terse response. 0.99. What is the ratio of the Population (in %) in Italy in 1998 to that in 2000?
Ensure brevity in your answer.  1.01. What is the ratio of the Population (in %) of Kyrgyz Republic in 1998 to that in 2000?
Give a very brief answer. 0.98. What is the ratio of the Population (in %) in Low & middle income in 1999 to that in 2000?
Give a very brief answer. 0.99. What is the ratio of the Population (in %) in Italy in 1999 to that in 2000?
Make the answer very short. 1. What is the ratio of the Population (in %) of Jamaica in 1999 to that in 2000?
Provide a succinct answer. 1. What is the ratio of the Population (in %) of Kyrgyz Republic in 1999 to that in 2000?
Provide a short and direct response. 0.99. What is the difference between the highest and the second highest Population (in %) in Low & middle income?
Offer a very short reply. 0.4. What is the difference between the highest and the second highest Population (in %) in Italy?
Your answer should be compact. 0.09. What is the difference between the highest and the second highest Population (in %) in Jamaica?
Your answer should be compact. 0.17. What is the difference between the highest and the second highest Population (in %) in Kyrgyz Republic?
Provide a short and direct response. 0.67. What is the difference between the highest and the lowest Population (in %) in Low & middle income?
Make the answer very short. 1.84. What is the difference between the highest and the lowest Population (in %) of Italy?
Your response must be concise. 1. What is the difference between the highest and the lowest Population (in %) of Jamaica?
Offer a very short reply. 1.17. What is the difference between the highest and the lowest Population (in %) in Kyrgyz Republic?
Provide a succinct answer. 2.67. 